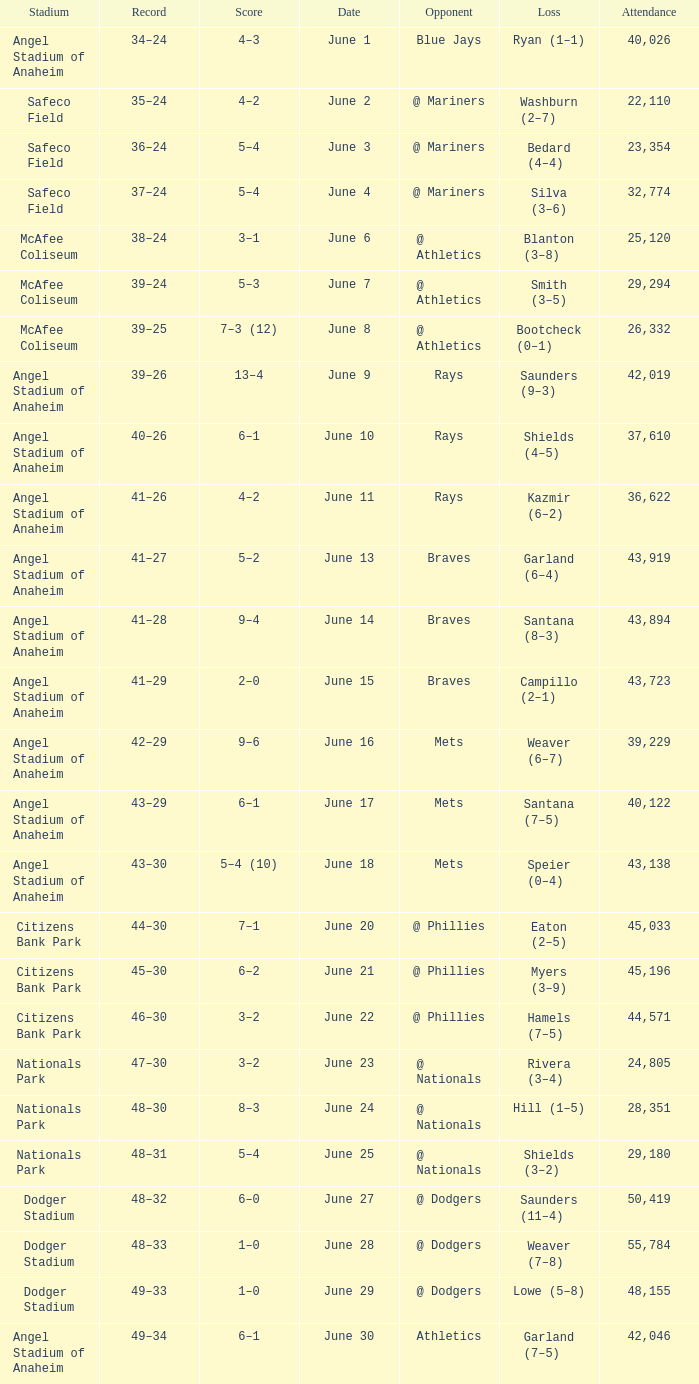What was the score of the game against the Braves with a record of 41–27? 5–2. 